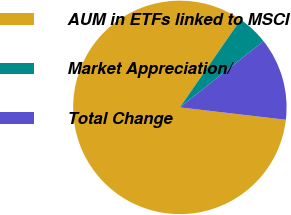<chart> <loc_0><loc_0><loc_500><loc_500><pie_chart><fcel>AUM in ETFs linked to MSCI<fcel>Market Appreciation/<fcel>Total Change<nl><fcel>82.8%<fcel>4.7%<fcel>12.51%<nl></chart> 